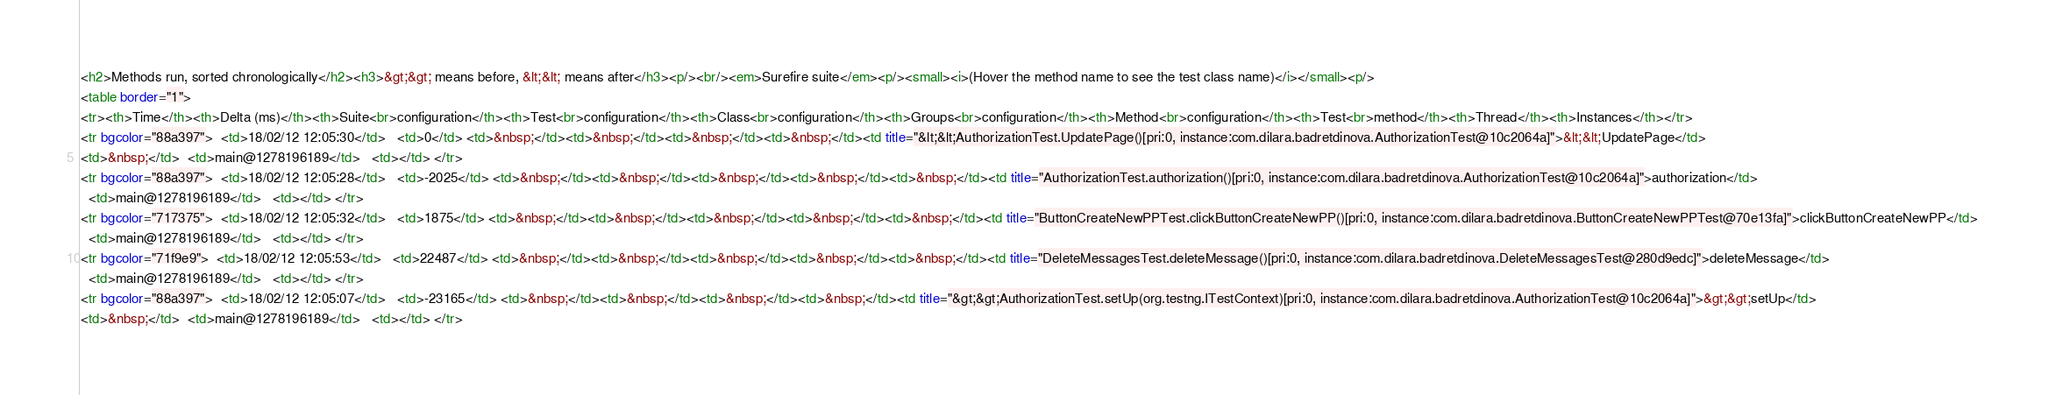Convert code to text. <code><loc_0><loc_0><loc_500><loc_500><_HTML_><h2>Methods run, sorted chronologically</h2><h3>&gt;&gt; means before, &lt;&lt; means after</h3><p/><br/><em>Surefire suite</em><p/><small><i>(Hover the method name to see the test class name)</i></small><p/>
<table border="1">
<tr><th>Time</th><th>Delta (ms)</th><th>Suite<br>configuration</th><th>Test<br>configuration</th><th>Class<br>configuration</th><th>Groups<br>configuration</th><th>Method<br>configuration</th><th>Test<br>method</th><th>Thread</th><th>Instances</th></tr>
<tr bgcolor="88a397">  <td>18/02/12 12:05:30</td>   <td>0</td> <td>&nbsp;</td><td>&nbsp;</td><td>&nbsp;</td><td>&nbsp;</td><td title="&lt;&lt;AuthorizationTest.UpdatePage()[pri:0, instance:com.dilara.badretdinova.AuthorizationTest@10c2064a]">&lt;&lt;UpdatePage</td> 
<td>&nbsp;</td>  <td>main@1278196189</td>   <td></td> </tr>
<tr bgcolor="88a397">  <td>18/02/12 12:05:28</td>   <td>-2025</td> <td>&nbsp;</td><td>&nbsp;</td><td>&nbsp;</td><td>&nbsp;</td><td>&nbsp;</td><td title="AuthorizationTest.authorization()[pri:0, instance:com.dilara.badretdinova.AuthorizationTest@10c2064a]">authorization</td> 
  <td>main@1278196189</td>   <td></td> </tr>
<tr bgcolor="717375">  <td>18/02/12 12:05:32</td>   <td>1875</td> <td>&nbsp;</td><td>&nbsp;</td><td>&nbsp;</td><td>&nbsp;</td><td>&nbsp;</td><td title="ButtonCreateNewPPTest.clickButtonCreateNewPP()[pri:0, instance:com.dilara.badretdinova.ButtonCreateNewPPTest@70e13fa]">clickButtonCreateNewPP</td> 
  <td>main@1278196189</td>   <td></td> </tr>
<tr bgcolor="71f9e9">  <td>18/02/12 12:05:53</td>   <td>22487</td> <td>&nbsp;</td><td>&nbsp;</td><td>&nbsp;</td><td>&nbsp;</td><td>&nbsp;</td><td title="DeleteMessagesTest.deleteMessage()[pri:0, instance:com.dilara.badretdinova.DeleteMessagesTest@280d9edc]">deleteMessage</td> 
  <td>main@1278196189</td>   <td></td> </tr>
<tr bgcolor="88a397">  <td>18/02/12 12:05:07</td>   <td>-23165</td> <td>&nbsp;</td><td>&nbsp;</td><td>&nbsp;</td><td>&nbsp;</td><td title="&gt;&gt;AuthorizationTest.setUp(org.testng.ITestContext)[pri:0, instance:com.dilara.badretdinova.AuthorizationTest@10c2064a]">&gt;&gt;setUp</td> 
<td>&nbsp;</td>  <td>main@1278196189</td>   <td></td> </tr></code> 